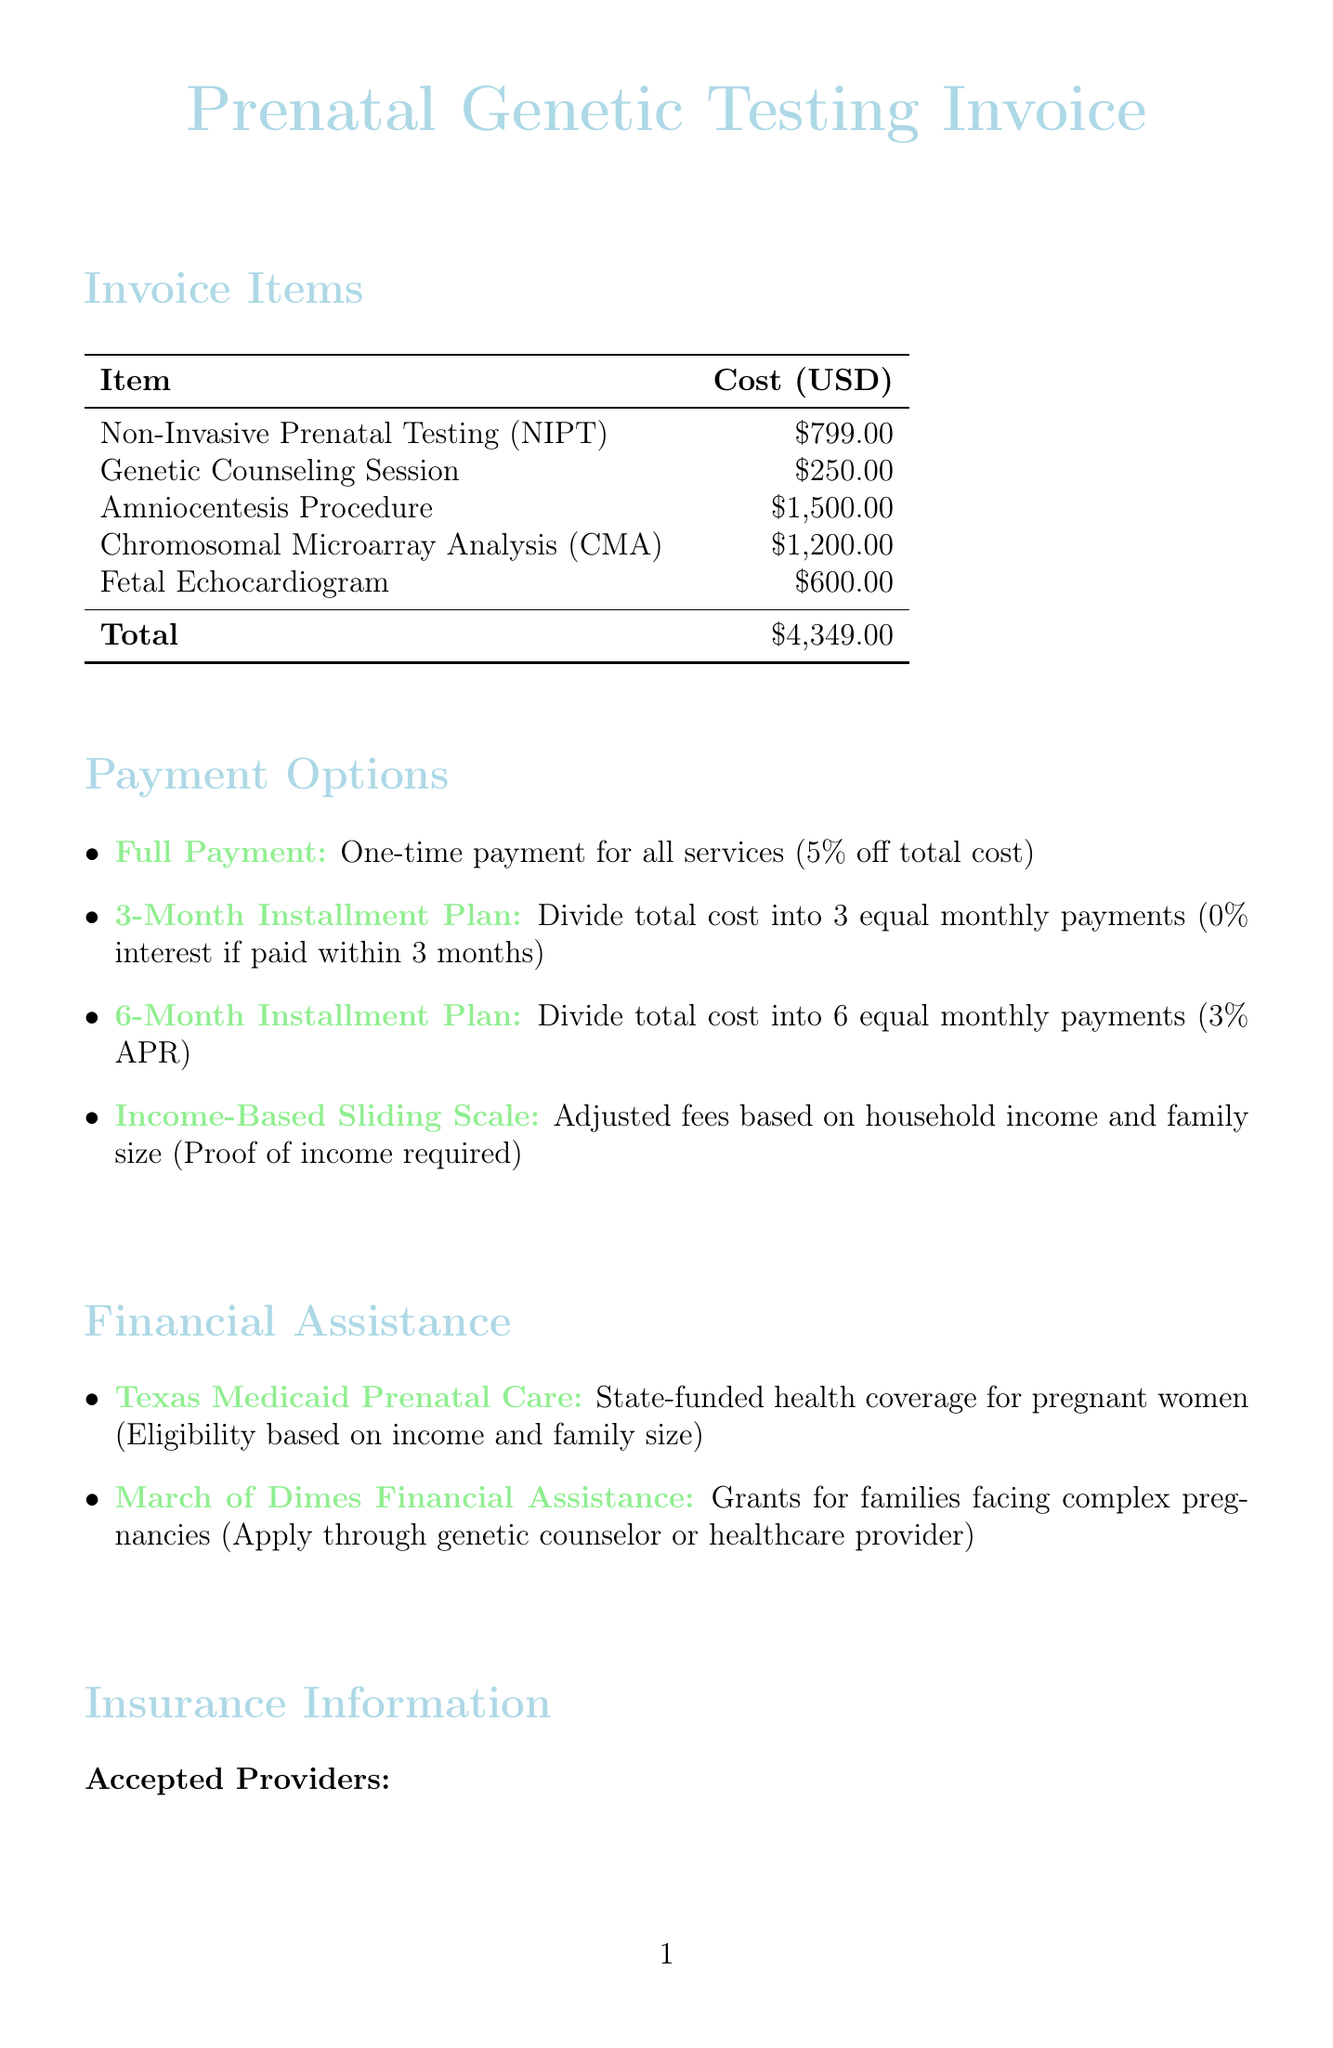What is the cost of Amniocentesis Procedure? The cost is listed under the invoice items in the document, specifically for the Amniocentesis Procedure.
Answer: $1500.00 What discount is offered for full payment? The discount for full payment is detailed in the payment options section of the document.
Answer: 5% off total cost How many providers are accepted for insurance? The number of accepted providers can be found in the insurance information section of the document.
Answer: 5 What is the total cost of all services? The total cost is calculated from the individual costs of the invoice items summarized at the end of that section.
Answer: $4,349.00 What is the interest rate for the 6-Month Installment Plan? The interest for the 6-Month Installment Plan is mentioned in the payment options section.
Answer: 3% APR Which program offers state-funded health coverage? The financial assistance section in the document mentions programs that offer help, specifically designed for pregnant women.
Answer: Texas Medicaid Prenatal Care What is the eligibility requirement for the Income-Based Sliding Scale? The eligibility requirement is stated in the payment options regarding adjusted fees.
Answer: Proof of income required What procedure evaluates the baby's heart structure? The document lists a specific procedure aimed at assessing the condition of the baby's heart under invoice items.
Answer: Fetal Echocardiogram What is the application process for March of Dimes Financial Assistance? The process is briefly described in the financial assistance section of the document.
Answer: Through genetic counselor or healthcare provider 